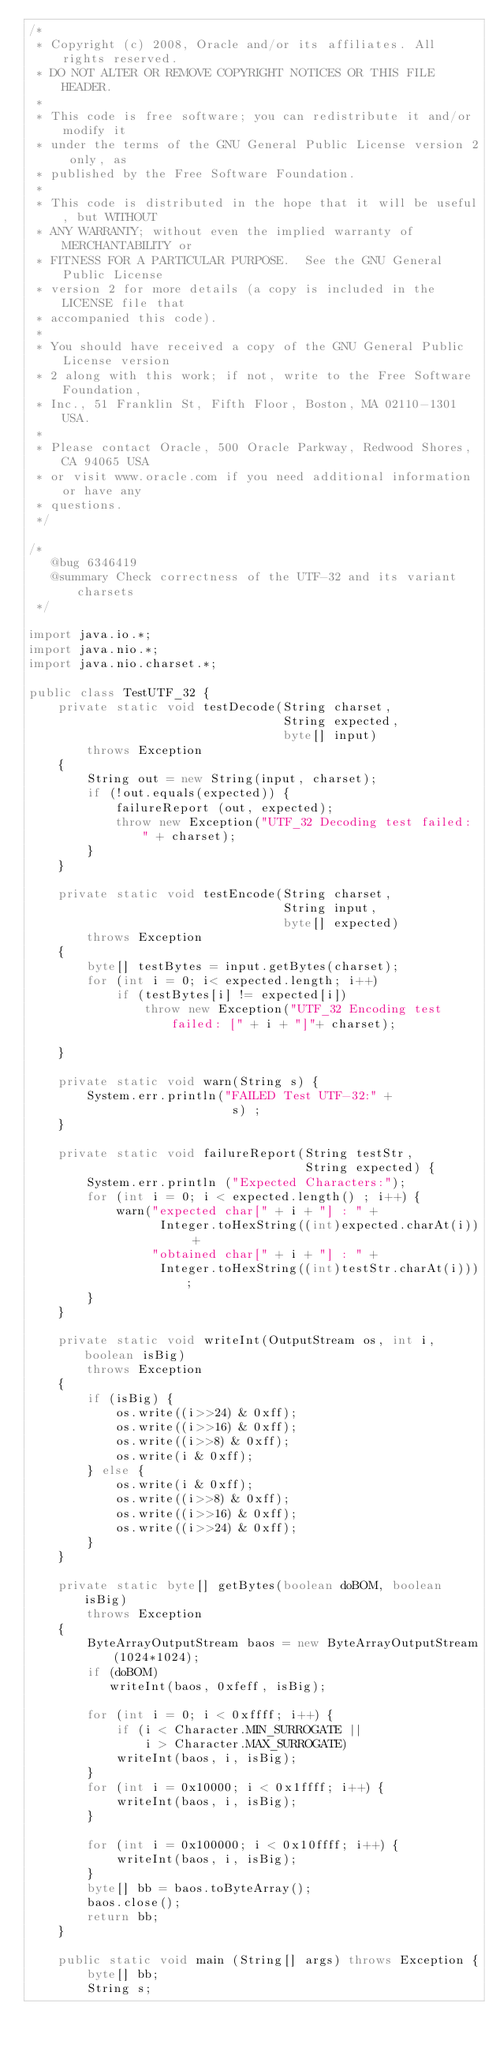Convert code to text. <code><loc_0><loc_0><loc_500><loc_500><_Java_>/*
 * Copyright (c) 2008, Oracle and/or its affiliates. All rights reserved.
 * DO NOT ALTER OR REMOVE COPYRIGHT NOTICES OR THIS FILE HEADER.
 *
 * This code is free software; you can redistribute it and/or modify it
 * under the terms of the GNU General Public License version 2 only, as
 * published by the Free Software Foundation.
 *
 * This code is distributed in the hope that it will be useful, but WITHOUT
 * ANY WARRANTY; without even the implied warranty of MERCHANTABILITY or
 * FITNESS FOR A PARTICULAR PURPOSE.  See the GNU General Public License
 * version 2 for more details (a copy is included in the LICENSE file that
 * accompanied this code).
 *
 * You should have received a copy of the GNU General Public License version
 * 2 along with this work; if not, write to the Free Software Foundation,
 * Inc., 51 Franklin St, Fifth Floor, Boston, MA 02110-1301 USA.
 *
 * Please contact Oracle, 500 Oracle Parkway, Redwood Shores, CA 94065 USA
 * or visit www.oracle.com if you need additional information or have any
 * questions.
 */

/*
   @bug 6346419
   @summary Check correctness of the UTF-32 and its variant charsets
 */

import java.io.*;
import java.nio.*;
import java.nio.charset.*;

public class TestUTF_32 {
    private static void testDecode(String charset,
                                   String expected,
                                   byte[] input)
        throws Exception
    {
        String out = new String(input, charset);
        if (!out.equals(expected)) {
            failureReport (out, expected);
            throw new Exception("UTF_32 Decoding test failed: " + charset);
        }
    }

    private static void testEncode(String charset,
                                   String input,
                                   byte[] expected)
        throws Exception
    {
        byte[] testBytes = input.getBytes(charset);
        for (int i = 0; i< expected.length; i++)
            if (testBytes[i] != expected[i])
                throw new Exception("UTF_32 Encoding test failed: [" + i + "]"+ charset);

    }

    private static void warn(String s) {
        System.err.println("FAILED Test UTF-32:" +
                            s) ;
    }

    private static void failureReport(String testStr,
                                      String expected) {
        System.err.println ("Expected Characters:");
        for (int i = 0; i < expected.length() ; i++) {
            warn("expected char[" + i + "] : " +
                  Integer.toHexString((int)expected.charAt(i)) +
                 "obtained char[" + i + "] : " +
                  Integer.toHexString((int)testStr.charAt(i)));
        }
    }

    private static void writeInt(OutputStream os, int i, boolean isBig)
        throws Exception
    {
        if (isBig) {
            os.write((i>>24) & 0xff);
            os.write((i>>16) & 0xff);
            os.write((i>>8) & 0xff);
            os.write(i & 0xff);
        } else {
            os.write(i & 0xff);
            os.write((i>>8) & 0xff);
            os.write((i>>16) & 0xff);
            os.write((i>>24) & 0xff);
        }
    }

    private static byte[] getBytes(boolean doBOM, boolean isBig)
        throws Exception
    {
        ByteArrayOutputStream baos = new ByteArrayOutputStream(1024*1024);
        if (doBOM)
           writeInt(baos, 0xfeff, isBig);

        for (int i = 0; i < 0xffff; i++) {
            if (i < Character.MIN_SURROGATE ||
                i > Character.MAX_SURROGATE)
            writeInt(baos, i, isBig);
        }
        for (int i = 0x10000; i < 0x1ffff; i++) {
            writeInt(baos, i, isBig);
        }

        for (int i = 0x100000; i < 0x10ffff; i++) {
            writeInt(baos, i, isBig);
        }
        byte[] bb = baos.toByteArray();
        baos.close();
        return bb;
    }

    public static void main (String[] args) throws Exception {
        byte[] bb;
        String s;
</code> 